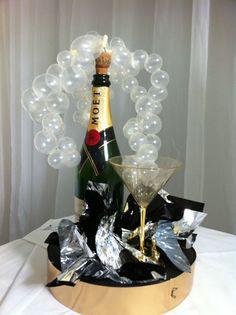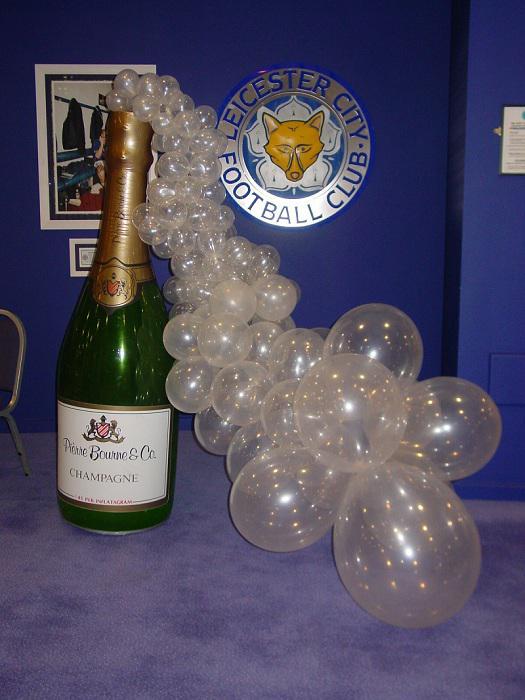The first image is the image on the left, the second image is the image on the right. Examine the images to the left and right. Is the description "There is a white arch of balloons that attached to a big bottle that is over an entrance door." accurate? Answer yes or no. No. The first image is the image on the left, the second image is the image on the right. Analyze the images presented: Is the assertion "A bottle is on the right side of a door." valid? Answer yes or no. No. 